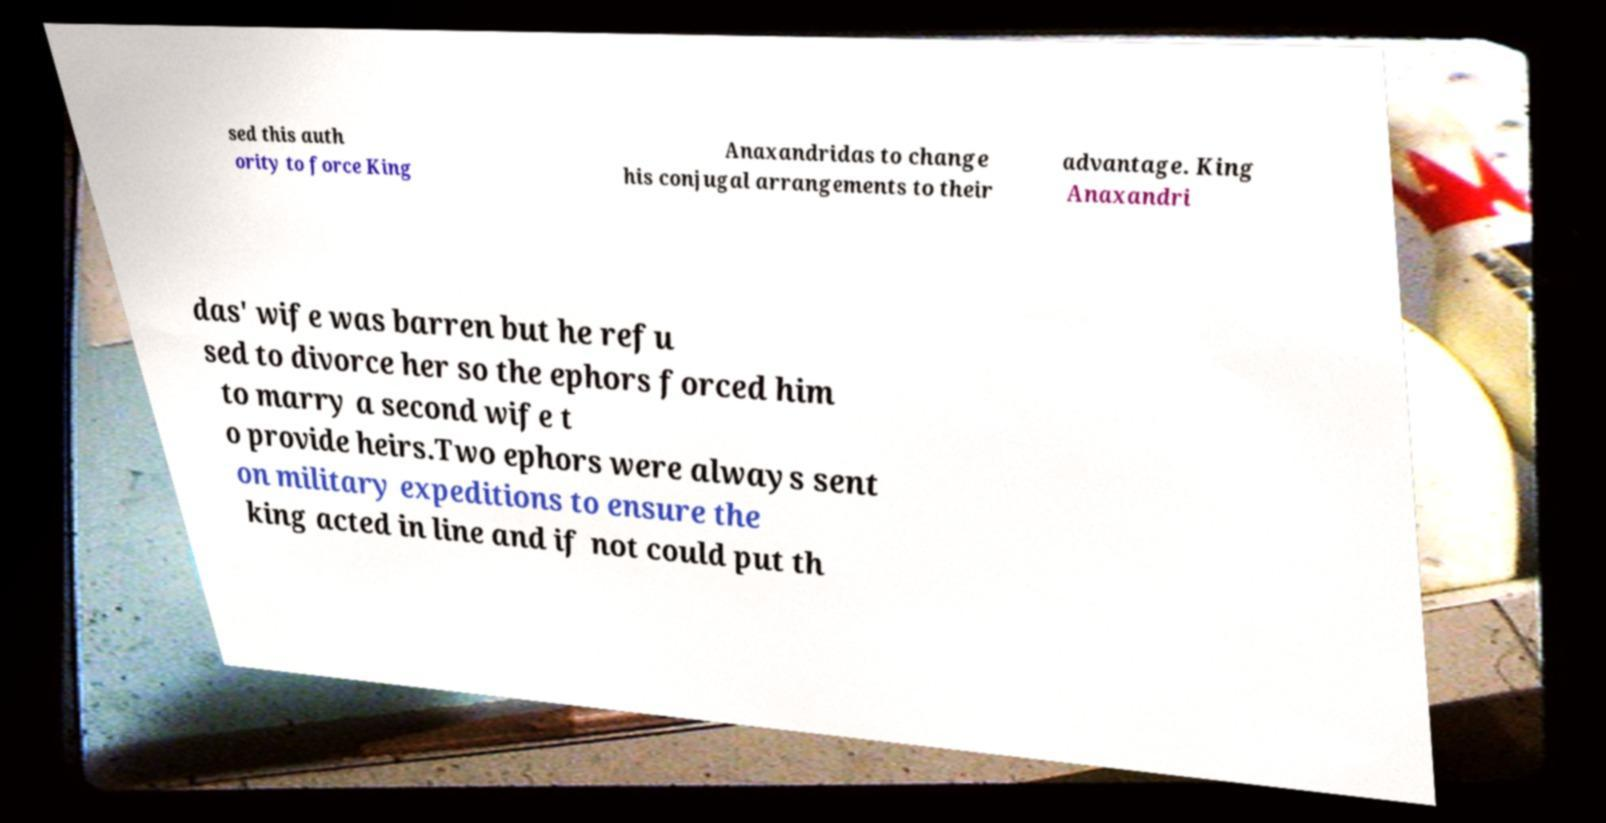Can you accurately transcribe the text from the provided image for me? sed this auth ority to force King Anaxandridas to change his conjugal arrangements to their advantage. King Anaxandri das' wife was barren but he refu sed to divorce her so the ephors forced him to marry a second wife t o provide heirs.Two ephors were always sent on military expeditions to ensure the king acted in line and if not could put th 